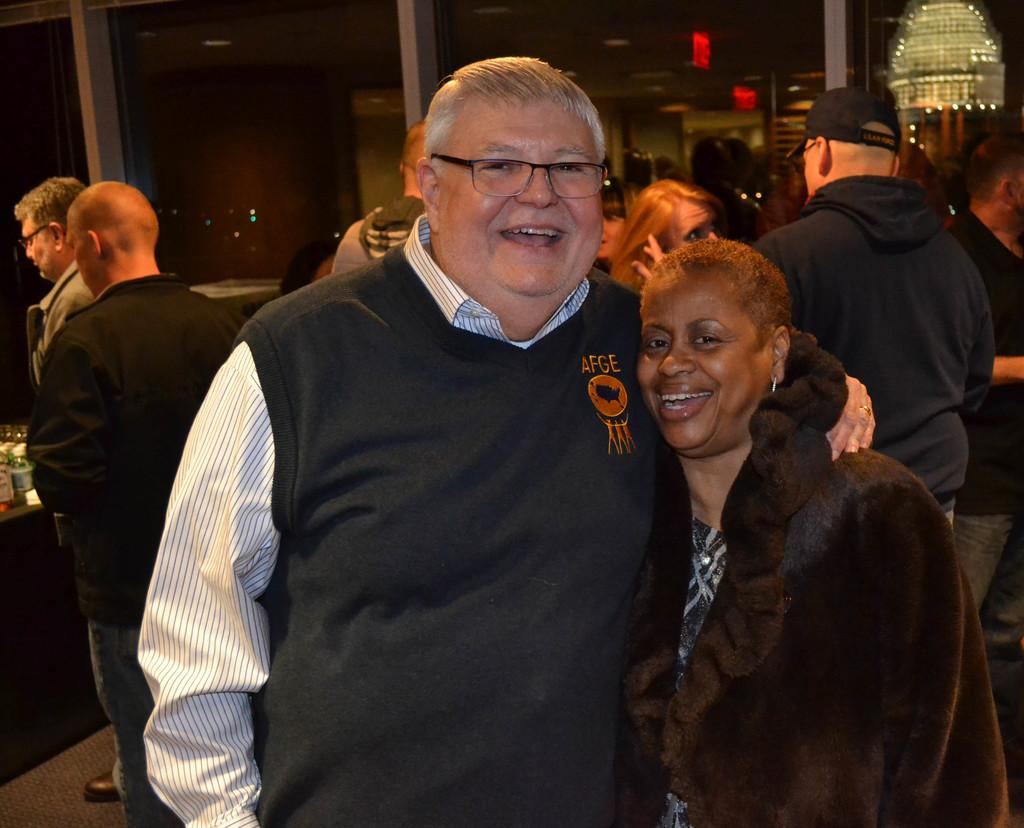How many people are in the room? There are people in the room, but the exact number is not specified. What is a feature of the room that allows light to enter? There is a glass window in the room. What piece of furniture is present in the room? There is a table in the room. What objects are placed on the table? There are bottles placed on the table. What type of ticket is visible on the table? There is no ticket present on the table in the image. Can you describe the detail on the people's mittens in the room? There is no mention of mittens or any specific details on the people's clothing in the image. 